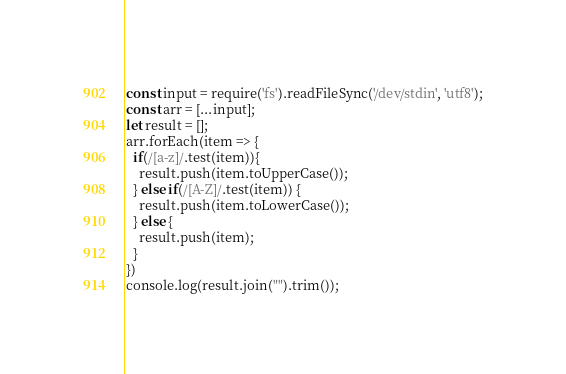<code> <loc_0><loc_0><loc_500><loc_500><_JavaScript_>const input = require('fs').readFileSync('/dev/stdin', 'utf8');
const arr = [...input];
let result = [];
arr.forEach(item => {
  if(/[a-z]/.test(item)){
    result.push(item.toUpperCase());
  } else if(/[A-Z]/.test(item)) {
    result.push(item.toLowerCase());
  } else {
    result.push(item);
  }
})
console.log(result.join("").trim());
</code> 